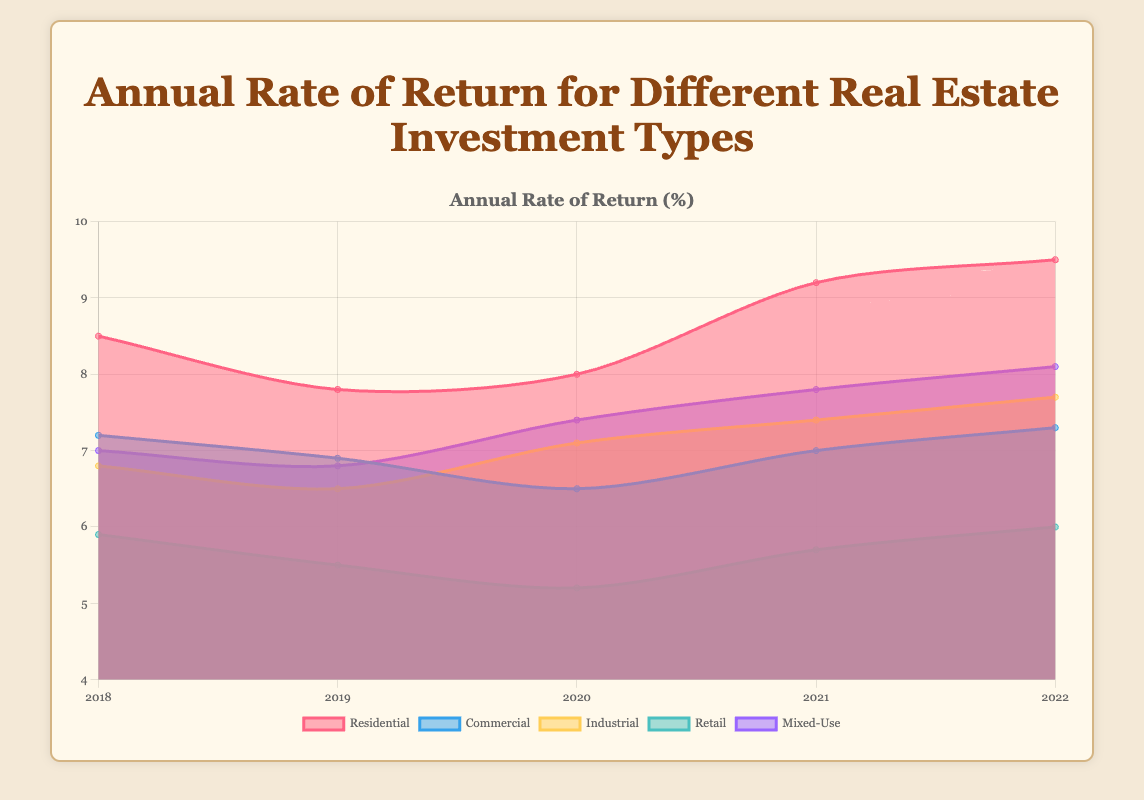What is the title of the chart? The title of the chart is usually displayed at the top and provides an overview of the chart's subject matter.
Answer: Annual Rate of Return for Different Real Estate Investment Types How many investment types are compared in the chart? Count the different labels or legend entries on the figure for each investment type.
Answer: Five Which investment type had the highest rate of return in 2022? Look at the data points on the far right side of the chart for 2022 and identify the highest value.
Answer: Residential How did the retail investment type's rate of return change from 2018 to 2022? Find the value for retail in 2018 and 2022, and calculate the difference: 6.0 (2022) - 5.9 (2018).
Answer: Increased by 0.1% Which investment type consistently showed the lowest rate of return? Identify the investment type that has the lowest data points throughout the years displayed.
Answer: Retail What is the average rate of return for industrial investments over the given years? Sum the rates of return for industrial investments from 2018 to 2022 and divide by the number of years: (6.8 + 6.5 + 7.1 + 7.4 + 7.7) / 5.
Answer: 7.1% Which year saw the highest overall increase in the rate of return for residential investments? Compare the year-to-year changes for residential investments and identify the year with the largest increase.
Answer: 2021 Between which years did mixed-use investments see the largest year-to-year increase in rate of return? Calculate the year-to-year differences for mixed-use investments and identify the largest increase: (7.8 - 7.4), (8.1 - 7.8).
Answer: 2020 to 2021 How did the annual rate of return for industrial investments compare to commercial investments in 2020? Compare the values for industrial and commercial investments in 2020: 7.1 (Industrial) vs. 6.5 (Commercial).
Answer: Industrial was higher Which investment type showed a more stable return over time, commercial or residential? Evaluate the consistency of year-to-year changes in the rate of return for both commercial and residential investments.
Answer: Commercial 